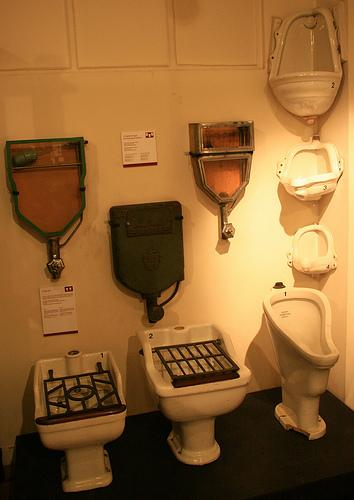Mention the primary objects in the image and their arrangement. A group of nine toilets and urinals, floor-mounted and corner-mounted, displayed in a museum-like setting. Give a summary of the image with a focus on the colors and materials. A mix of white bathroom fixtures with green tanks, black bases, and metallic flushes displayed in a white-walled room with a black floor. Provide a brief overview of the scene in the image. A display of various bathroom fixtures, including toilets and urinals, with some having signature characteristics, such as tanks and grates. Identify the primary subject in the image and their unique features. A collection of various toilets and urinals, each having distinct aspects like corner-mounting, wall-mounted tanks, and metal grates. Describe the general theme surrounding the objects in the image. An exhibition of multiple toilets and urinals, showcasing different models, features, and installation styles. Explain the setup of the image focusing on how the objects are placed. A variety of toilets and urinals positioned in a corner, with some displayed on the floor and others mounted on the wall. Provide a concise description of the main components of the image. An assortment of toilets and urinals, some with unique attributes like green tanks and metal grates, located in a room. Describe the image using informal language. A bunch of toilets and urinals, some with funky features like broken bases and grid tops, hanging out together in a space. Describe the image by concentrating on the unique characteristics of the objects. A showcase of assorted toilets and urinals, featuring distinct traits such as green tanks, metal grates, and broken bases. Provide a description of the image in a poetic manner. A symphony of porcelain and metal, where toilets and urinals harmoniously intermingle, transforming the mundane into an artful display. 